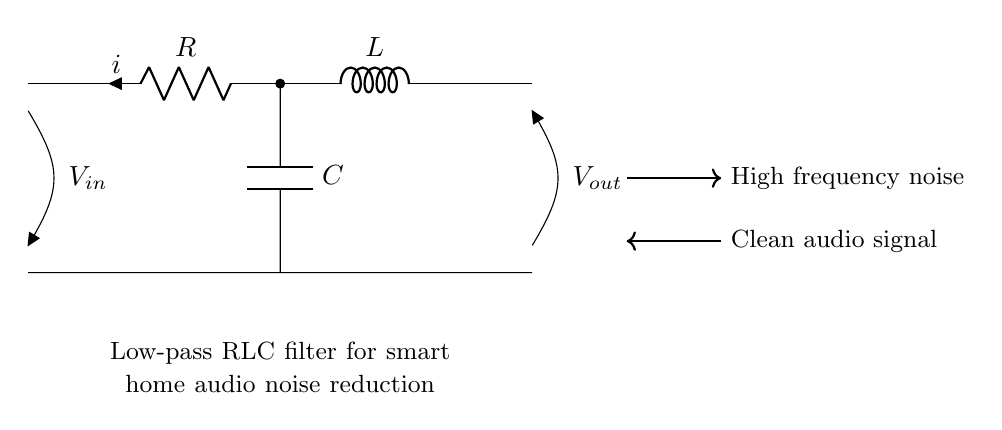What are the three main components in this circuit? The circuit consists of a resistor, an inductor, and a capacitor, which are the fundamental components of an RLC circuit.
Answer: Resistor, Inductor, Capacitor What is the purpose of this circuit? This circuit serves as a low-pass filter, which allows low-frequency signals to pass while attenuating high-frequency noise, making it suitable for audio applications.
Answer: Noise reduction What is the output voltage labeled as? In the diagram, the output voltage is indicated as V out, which reflects the clean audio signal after the filtering process.
Answer: V out What type of filter does this circuit represent? This circuit is a low-pass filter since it is designed to pass low-frequency signals while blocking higher-frequency components.
Answer: Low-pass filter What happens to high-frequency noise in this circuit? The circuit effectively attenuates high-frequency noise, allowing only the desired audio signal to pass through, thus improving sound quality.
Answer: Attenuated What is the relationship between the input and output voltages? The output voltage (V out) will be less than the input voltage (V in) if high-frequency noise is present, demonstrating the filtering effect of the circuit.
Answer: V out < V in 